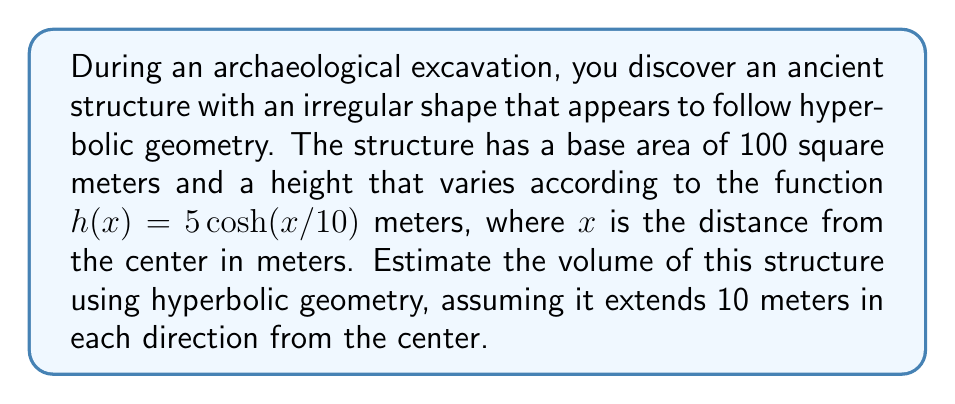Solve this math problem. To estimate the volume of this irregularly shaped ancient structure using hyperbolic geometry, we'll follow these steps:

1) The volume of a solid with a variable height can be calculated using the integral:

   $$V = \int_{-a}^{a} A \cdot h(x) \, dx$$

   where $A$ is the base area, $h(x)$ is the height function, and $[-a,a]$ is the interval over which the structure extends.

2) We're given:
   - Base area $A = 100$ m²
   - Height function $h(x) = 5 \cosh(x/10)$ m
   - The structure extends 10 meters in each direction, so $a = 10$

3) Substituting these into our volume integral:

   $$V = 100 \int_{-10}^{10} 5 \cosh(x/10) \, dx$$

4) Simplifying:

   $$V = 500 \int_{-10}^{10} \cosh(x/10) \, dx$$

5) To solve this, we use the integral of hyperbolic cosine:

   $$\int \cosh(ax) \, dx = \frac{1}{a} \sinh(ax) + C$$

6) Applying this to our integral:

   $$V = 500 \cdot 10 \left[\sinh(x/10)\right]_{-10}^{10}$$

7) Evaluating the bounds:

   $$V = 5000 [\sinh(1) - \sinh(-1)]$$

8) Recall that sinh is an odd function, so $\sinh(-1) = -\sinh(1)$:

   $$V = 5000 [2\sinh(1)]$$

9) $\sinh(1) \approx 1.1752$, so:

   $$V \approx 5000 \cdot 2 \cdot 1.1752 \approx 11752$$

Therefore, the estimated volume of the structure is approximately 11,752 cubic meters.
Answer: $11,752$ m³ 